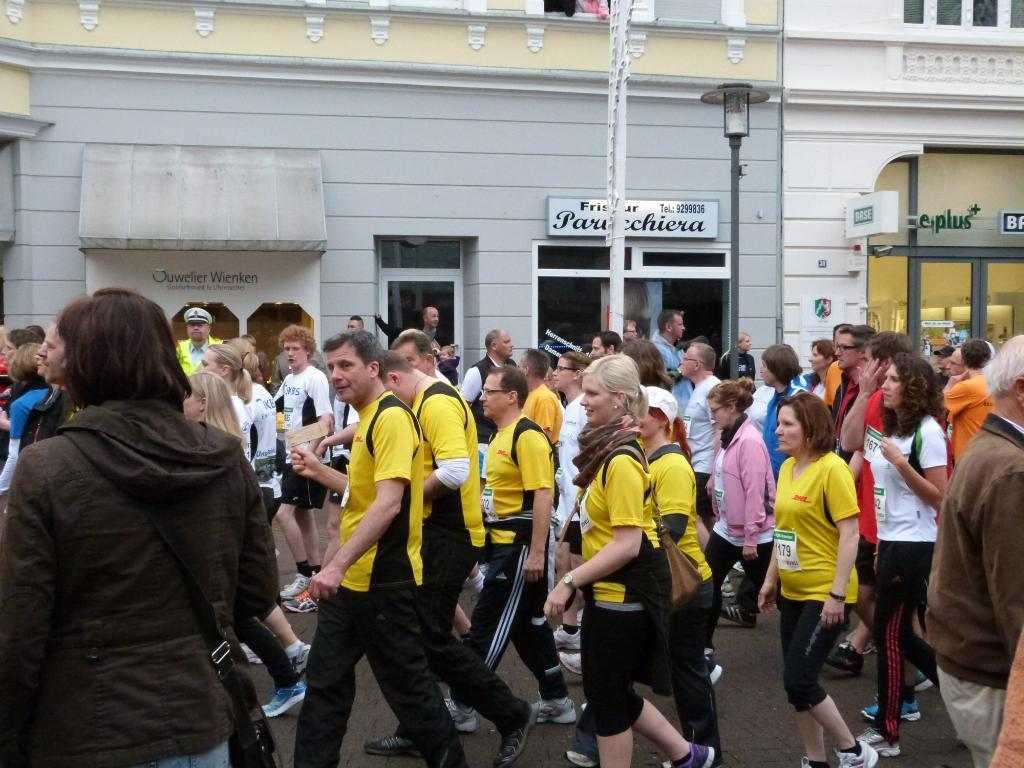What are the people in the image doing? There are groups of people walking on the road in the image. What can be seen in the distance behind the people? There are buildings in the background. Are there any signs or markers visible in the background? Yes, name boards are present in the background. What else can be seen in the background? A pole and a light pole are visible in the background. What type of soap is being used by the people walking on the road? There is no soap present in the image, and the people walking on the road are not using any soap. 